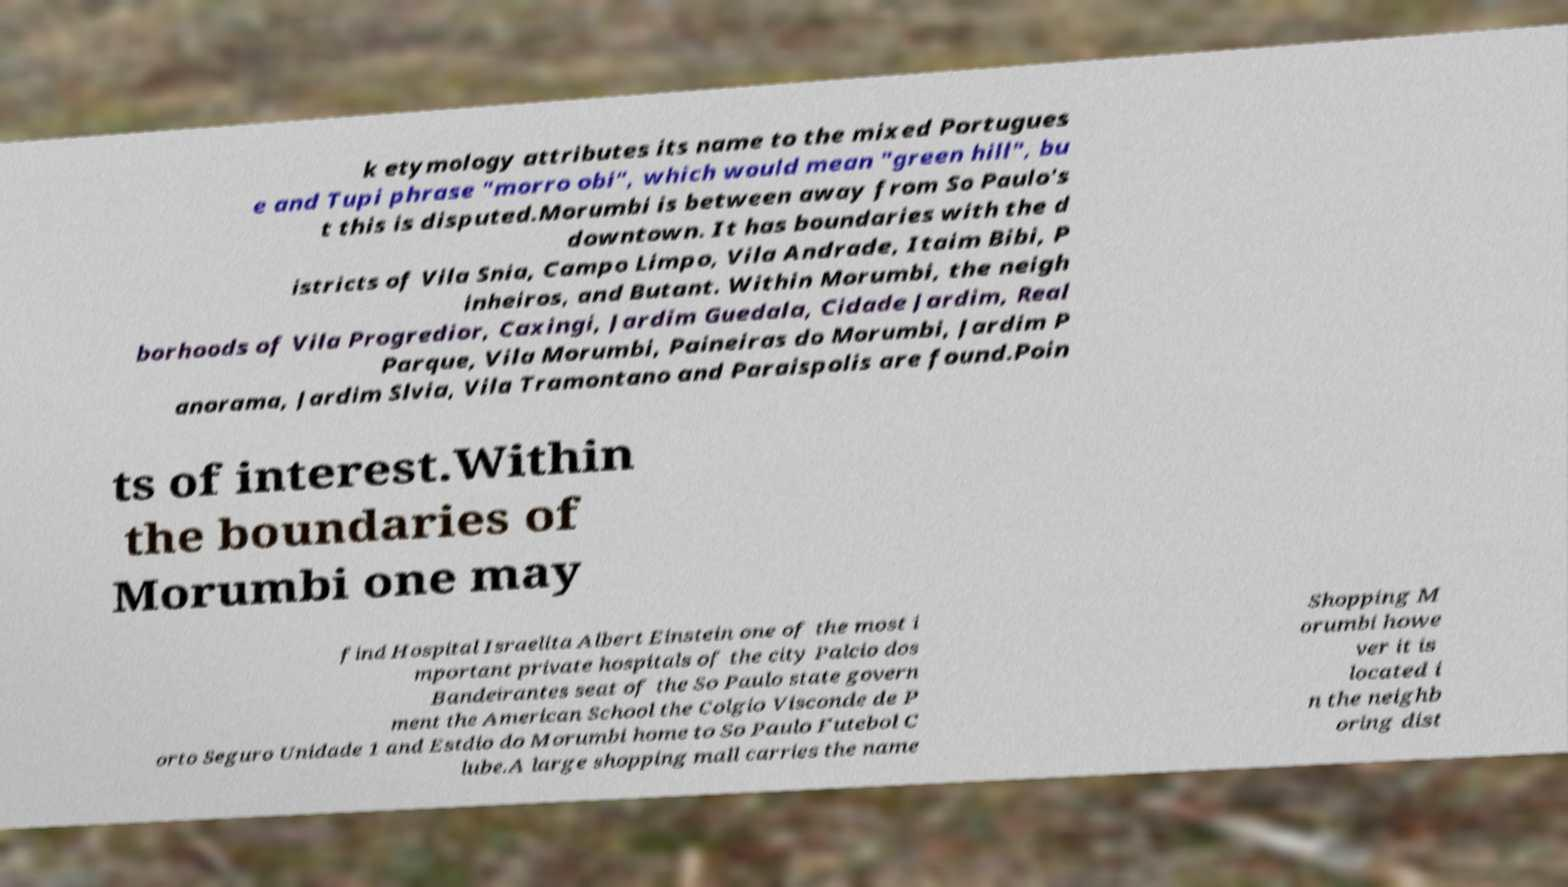Can you accurately transcribe the text from the provided image for me? k etymology attributes its name to the mixed Portugues e and Tupi phrase "morro obi", which would mean "green hill", bu t this is disputed.Morumbi is between away from So Paulo's downtown. It has boundaries with the d istricts of Vila Snia, Campo Limpo, Vila Andrade, Itaim Bibi, P inheiros, and Butant. Within Morumbi, the neigh borhoods of Vila Progredior, Caxingi, Jardim Guedala, Cidade Jardim, Real Parque, Vila Morumbi, Paineiras do Morumbi, Jardim P anorama, Jardim Slvia, Vila Tramontano and Paraispolis are found.Poin ts of interest.Within the boundaries of Morumbi one may find Hospital Israelita Albert Einstein one of the most i mportant private hospitals of the city Palcio dos Bandeirantes seat of the So Paulo state govern ment the American School the Colgio Visconde de P orto Seguro Unidade 1 and Estdio do Morumbi home to So Paulo Futebol C lube.A large shopping mall carries the name Shopping M orumbi howe ver it is located i n the neighb oring dist 